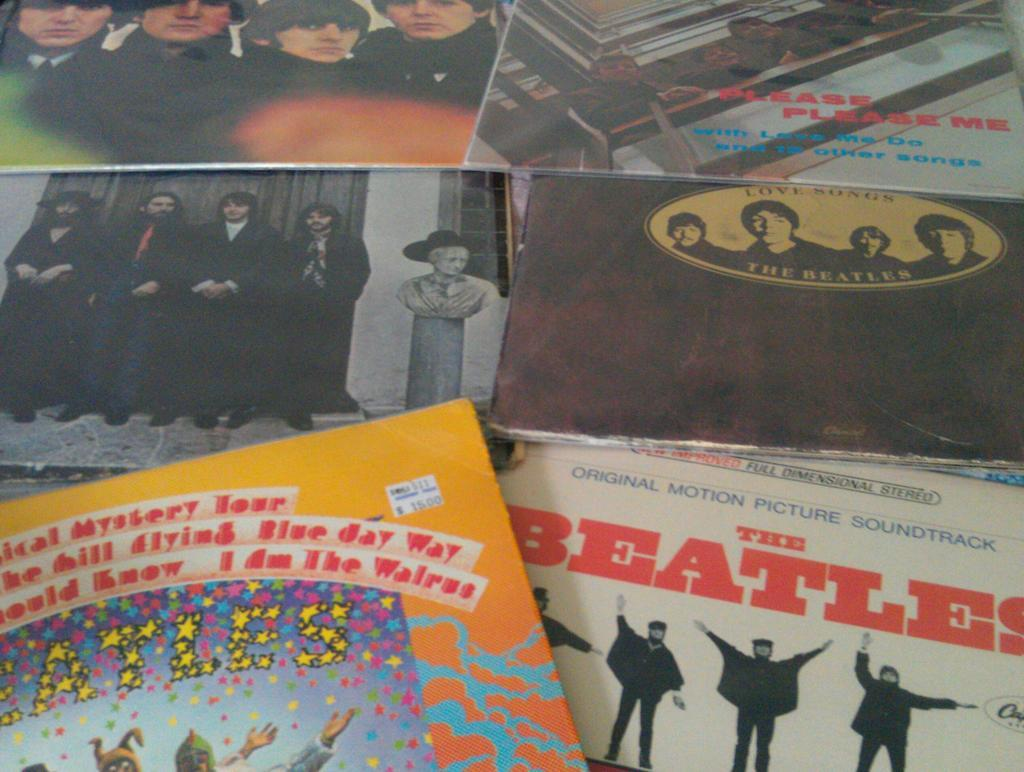<image>
Share a concise interpretation of the image provided. The Beatles albums all put together on top of a surface. 